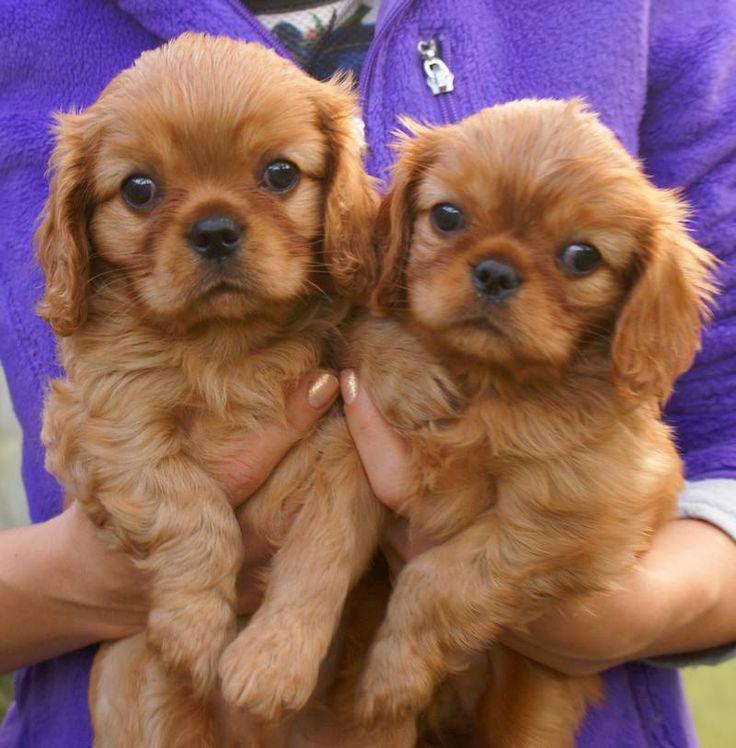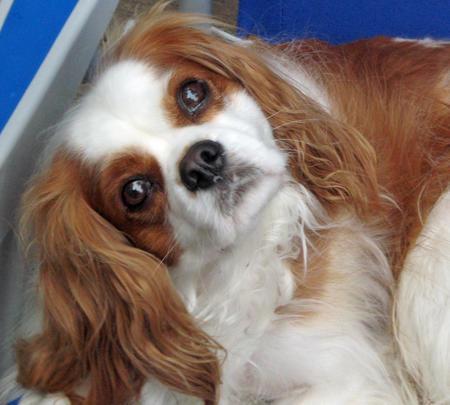The first image is the image on the left, the second image is the image on the right. Given the left and right images, does the statement "One image contains twice as many spaniel pups as the other, and one image includes a hand holding a puppy." hold true? Answer yes or no. Yes. The first image is the image on the left, the second image is the image on the right. Given the left and right images, does the statement "The left image contains exactly two dogs." hold true? Answer yes or no. Yes. 